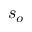<formula> <loc_0><loc_0><loc_500><loc_500>s _ { o }</formula> 